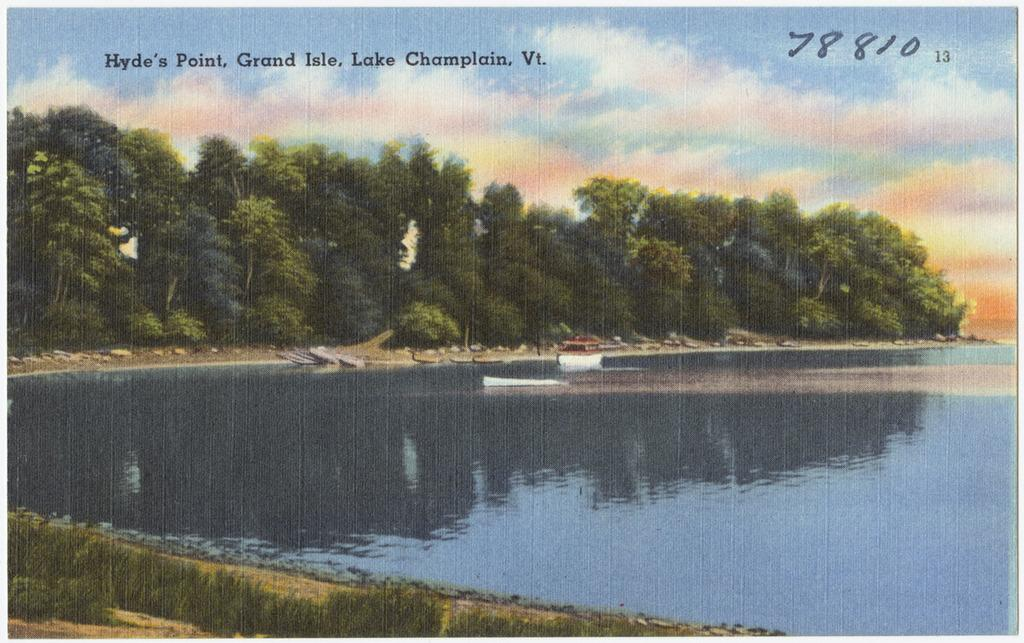What type of natural feature is present in the image? There is a lake in the image. What other natural elements can be seen in the image? There are trees in the image. What is visible in the background of the image? The sky is visible in the image. What is written or displayed at the top of the image? There is text visible at the top of the image. How many beds are visible in the image? There are no beds present in the image. Is the scene in the image particularly quiet or peaceful? The provided facts do not give any information about the noise level or peacefulness of the scene in the image. 